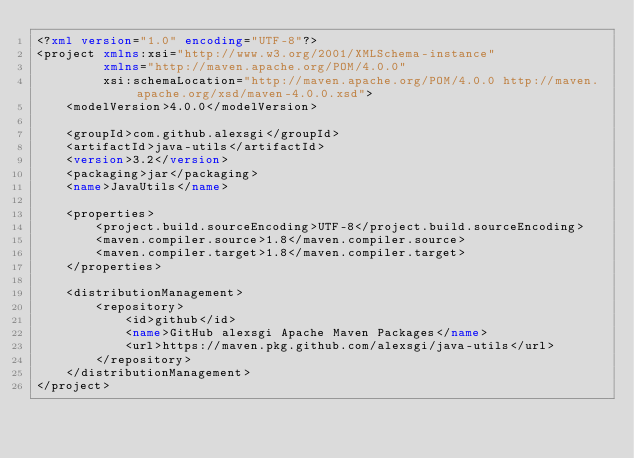<code> <loc_0><loc_0><loc_500><loc_500><_XML_><?xml version="1.0" encoding="UTF-8"?>
<project xmlns:xsi="http://www.w3.org/2001/XMLSchema-instance"
         xmlns="http://maven.apache.org/POM/4.0.0"
         xsi:schemaLocation="http://maven.apache.org/POM/4.0.0 http://maven.apache.org/xsd/maven-4.0.0.xsd">
    <modelVersion>4.0.0</modelVersion>

    <groupId>com.github.alexsgi</groupId>
    <artifactId>java-utils</artifactId>
    <version>3.2</version>
    <packaging>jar</packaging>
    <name>JavaUtils</name>

    <properties>
        <project.build.sourceEncoding>UTF-8</project.build.sourceEncoding>
        <maven.compiler.source>1.8</maven.compiler.source>
        <maven.compiler.target>1.8</maven.compiler.target>
    </properties>

    <distributionManagement>
        <repository>
            <id>github</id>
            <name>GitHub alexsgi Apache Maven Packages</name>
            <url>https://maven.pkg.github.com/alexsgi/java-utils</url>
        </repository>
    </distributionManagement>
</project></code> 